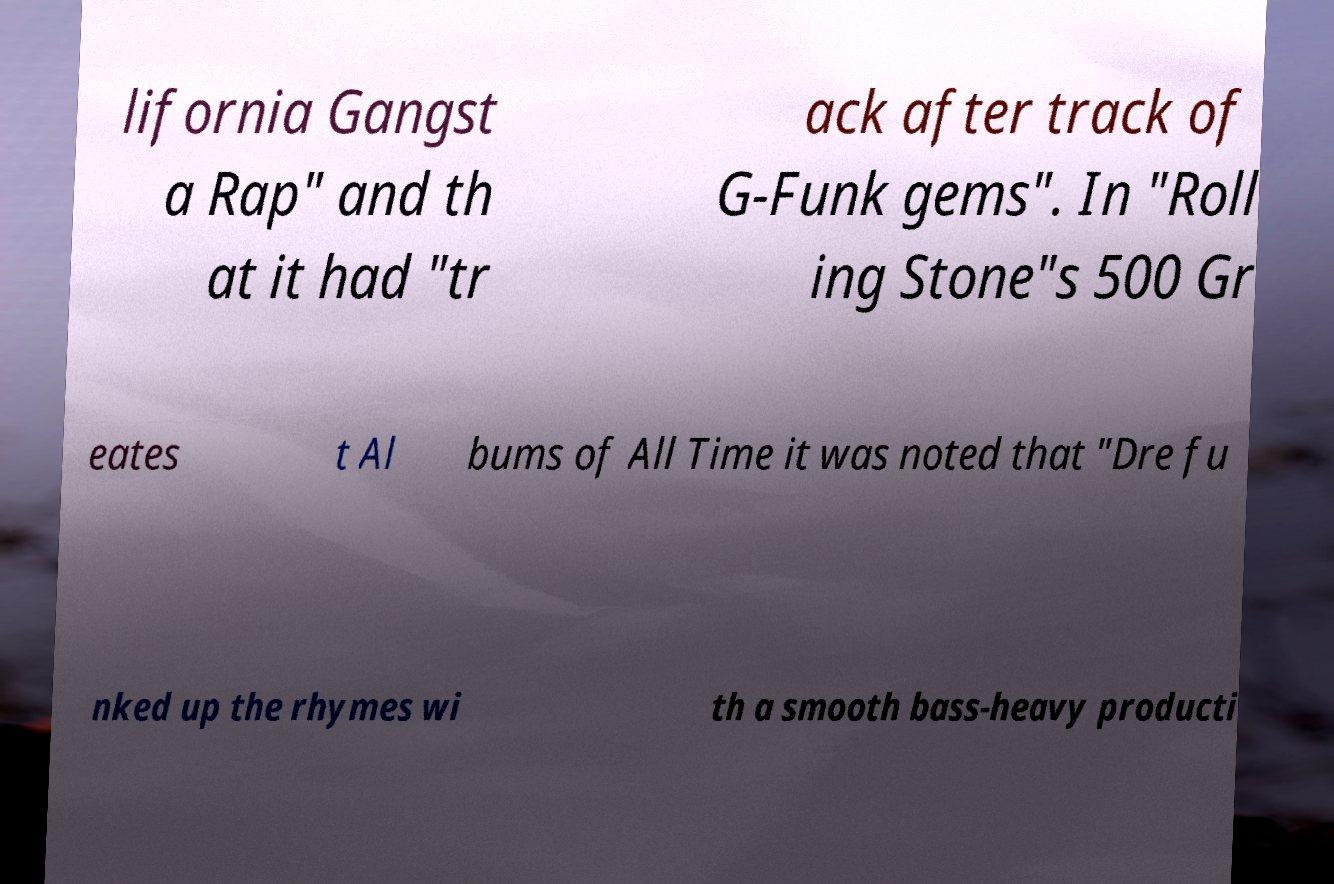There's text embedded in this image that I need extracted. Can you transcribe it verbatim? lifornia Gangst a Rap" and th at it had "tr ack after track of G-Funk gems". In "Roll ing Stone"s 500 Gr eates t Al bums of All Time it was noted that "Dre fu nked up the rhymes wi th a smooth bass-heavy producti 